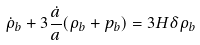Convert formula to latex. <formula><loc_0><loc_0><loc_500><loc_500>\dot { \rho } _ { b } + 3 \frac { \dot { a } } { a } ( \rho _ { b } + p _ { b } ) = 3 H \delta \rho _ { b }</formula> 